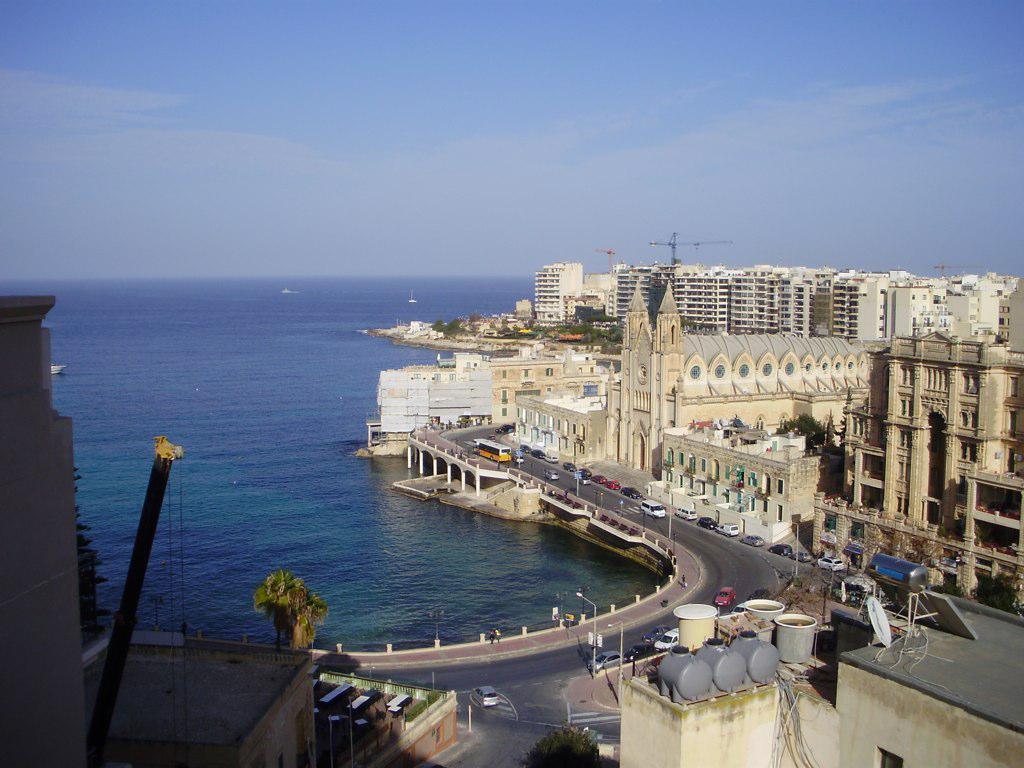How would you summarize this image in a sentence or two? This image is clicked from a top view. To the right there are buildings and trees. In front of the buildings there are vehicles moving on the roads. Beside the road there is the water. There are boats on the water. At the top there is the sky. 